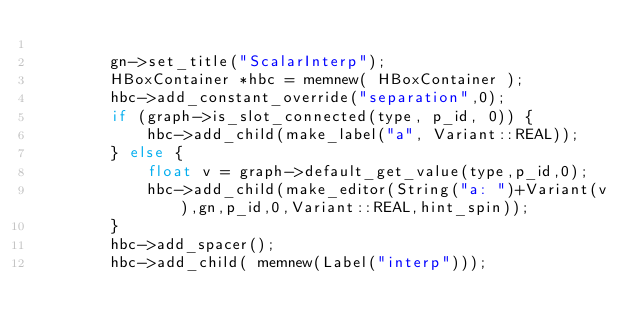<code> <loc_0><loc_0><loc_500><loc_500><_C++_>
		gn->set_title("ScalarInterp");
		HBoxContainer *hbc = memnew( HBoxContainer );
		hbc->add_constant_override("separation",0);
		if (graph->is_slot_connected(type, p_id, 0)) {
			hbc->add_child(make_label("a", Variant::REAL));
		} else {
			float v = graph->default_get_value(type,p_id,0);
			hbc->add_child(make_editor(String("a: ")+Variant(v),gn,p_id,0,Variant::REAL,hint_spin));
		}
		hbc->add_spacer();
		hbc->add_child( memnew(Label("interp")));</code> 